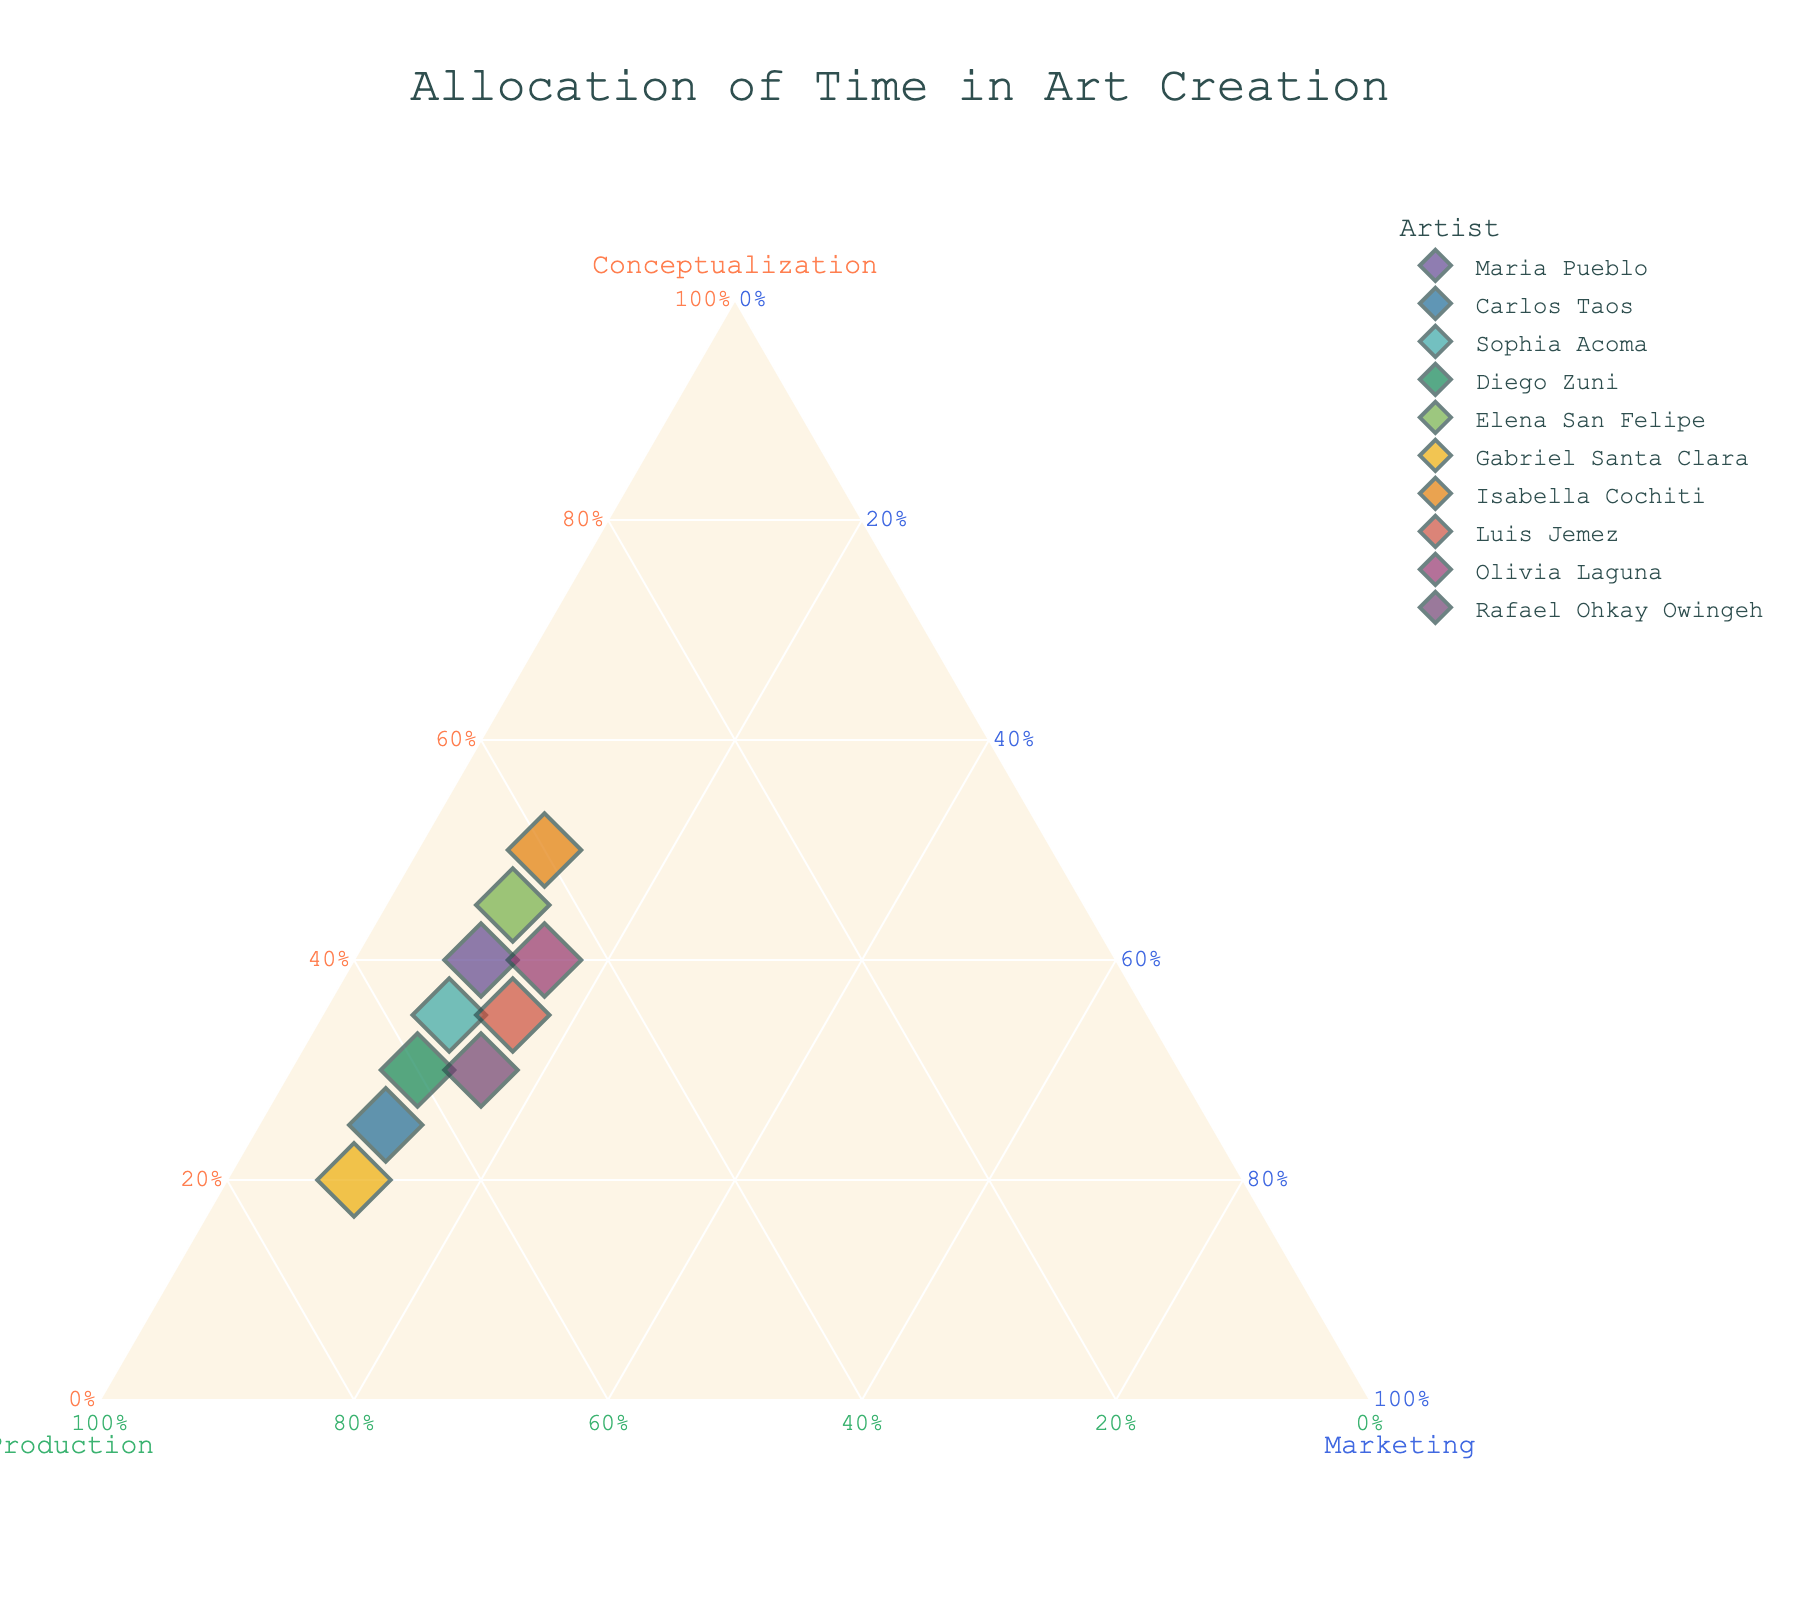How many artists are represented in the plot? By counting the data points represented in the plot's legend or by the number of distinct points on the plot.
Answer: 10 What is the title of the plot? The title is generally displayed at the top of the plot, providing an overview of what the figure represents.
Answer: Allocation of Time in Art Creation Which artist spends the highest proportion of time on conceptualization? By observing the points nearest to the "Conceptualization" axis, we can see which artist spends the most proportion of time on it.
Answer: Isabella Cochiti Which two artists have the closest allocation of time in all three aspects? By comparing the proximity of the points within the ternary plot, you can see which two artists' points are closest to one another.
Answer: Maria Pueblo and Olivia Laguna How is the axis labeled for the time spent on production? By looking at the plot, you can identify the axis on the ternary plot labeled for production.
Answer: Production What's the range of the time spent on marketing for all artists? Since marketing is fixed at 10 or 15 for all data points, identify the smallest and largest values on the "Marketing" axis.
Answer: 10-15% Which artists allocate 15% of their total time to marketing? By identifying the points closer to the marketing axis at the 15% mark and confirming the artists through the hover or legend information.
Answer: Luis Jemez, Olivia Laguna, Rafael Ohkay Owingeh Who spends more time on production, Carlos Taos or Diego Zuni? By comparing the points of Carlos Taos with Diego Zuni on the "Production" axis, locate which artist's point is closer to the production axis.
Answer: Carlos Taos Among the artists listed, which spends the least time on conceptualization? Find the point closest to the bottom of the "Conceptualization" axis, which represents the least time spent on it compared to other aspects.
Answer: Gabriel Santa Clara What is a unique characteristic you can infer from this ternary plot regarding marketing? Observing the plot shows that marketing proportions are almost constant for all artists with very limited variations.
Answer: Nearly equal for all artists 